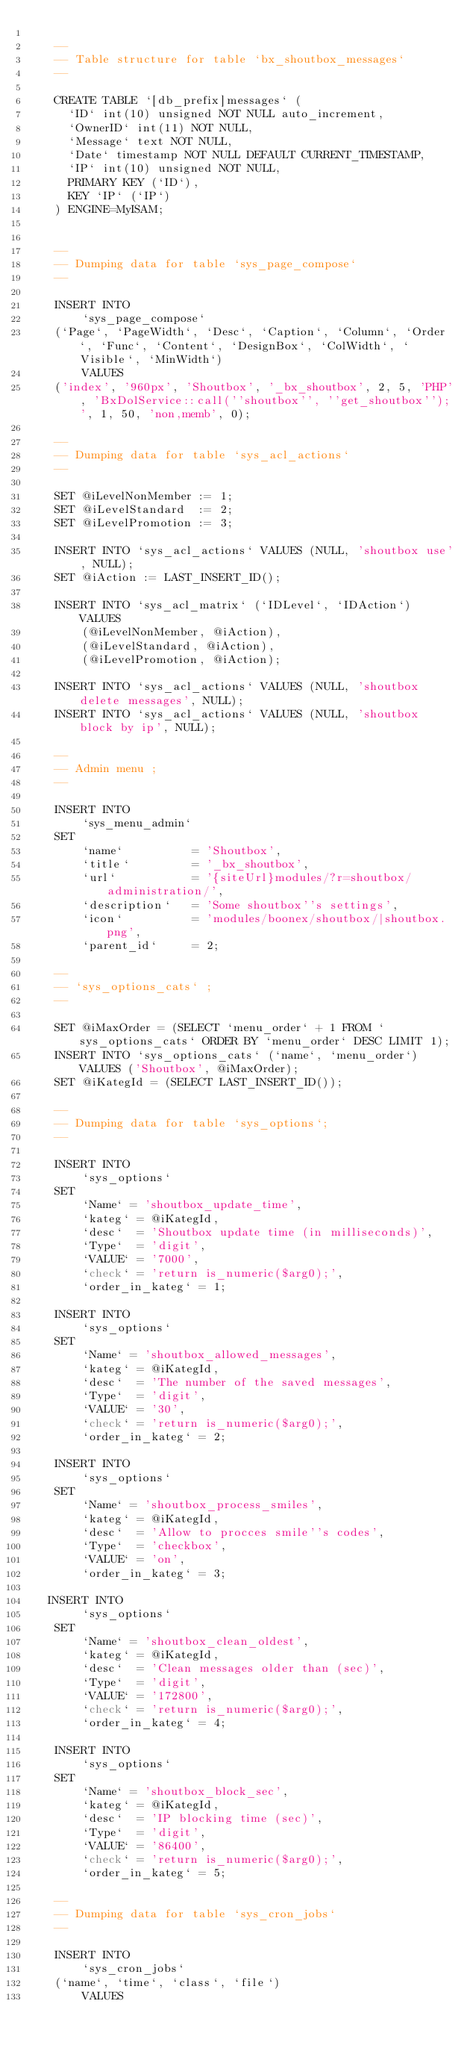Convert code to text. <code><loc_0><loc_0><loc_500><loc_500><_SQL_>
    --
    -- Table structure for table `bx_shoutbox_messages`
    --

    CREATE TABLE `[db_prefix]messages` (
      `ID` int(10) unsigned NOT NULL auto_increment,
      `OwnerID` int(11) NOT NULL,
      `Message` text NOT NULL,
      `Date` timestamp NOT NULL DEFAULT CURRENT_TIMESTAMP,
      `IP` int(10) unsigned NOT NULL,
      PRIMARY KEY (`ID`),
      KEY `IP` (`IP`)
    ) ENGINE=MyISAM;


    --
    -- Dumping data for table `sys_page_compose`
    --

    INSERT INTO 
        `sys_page_compose` 
    (`Page`, `PageWidth`, `Desc`, `Caption`, `Column`, `Order`, `Func`, `Content`, `DesignBox`, `ColWidth`, `Visible`, `MinWidth`)
        VALUES
    ('index', '960px', 'Shoutbox', '_bx_shoutbox', 2, 5, 'PHP', 'BxDolService::call(''shoutbox'', ''get_shoutbox'');', 1, 50, 'non,memb', 0);

    --
    -- Dumping data for table `sys_acl_actions`
    --

    SET @iLevelNonMember := 1;
    SET @iLevelStandard  := 2;
    SET @iLevelPromotion := 3;

    INSERT INTO `sys_acl_actions` VALUES (NULL, 'shoutbox use', NULL);
    SET @iAction := LAST_INSERT_ID();

    INSERT INTO `sys_acl_matrix` (`IDLevel`, `IDAction`) VALUES 
        (@iLevelNonMember, @iAction), 
        (@iLevelStandard, @iAction), 
        (@iLevelPromotion, @iAction);

    INSERT INTO `sys_acl_actions` VALUES (NULL, 'shoutbox delete messages', NULL);
    INSERT INTO `sys_acl_actions` VALUES (NULL, 'shoutbox block by ip', NULL);

    --
    -- Admin menu ;
    --

    INSERT INTO 
        `sys_menu_admin` 
    SET
        `name`          = 'Shoutbox',
        `title`         = '_bx_shoutbox', 
        `url`           = '{siteUrl}modules/?r=shoutbox/administration/',
        `description`   = 'Some shoutbox''s settings',
        `icon`          = 'modules/boonex/shoutbox/|shoutbox.png',
        `parent_id`     = 2;
    
    --
    -- `sys_options_cats` ;
    --

    SET @iMaxOrder = (SELECT `menu_order` + 1 FROM `sys_options_cats` ORDER BY `menu_order` DESC LIMIT 1);
    INSERT INTO `sys_options_cats` (`name`, `menu_order`) VALUES ('Shoutbox', @iMaxOrder);
    SET @iKategId = (SELECT LAST_INSERT_ID());

    --
    -- Dumping data for table `sys_options`;
    --

    INSERT INTO 
        `sys_options` 
    SET
        `Name` = 'shoutbox_update_time',
        `kateg` = @iKategId,
        `desc`  = 'Shoutbox update time (in milliseconds)',
        `Type`  = 'digit',
        `VALUE` = '7000',
        `check` = 'return is_numeric($arg0);',
        `order_in_kateg` = 1;

    INSERT INTO 
        `sys_options` 
    SET
        `Name` = 'shoutbox_allowed_messages',
        `kateg` = @iKategId,
        `desc`  = 'The number of the saved messages',
        `Type`  = 'digit',
        `VALUE` = '30',
        `check` = 'return is_numeric($arg0);',
        `order_in_kateg` = 2;
 
    INSERT INTO 
        `sys_options` 
    SET
        `Name` = 'shoutbox_process_smiles',
        `kateg` = @iKategId,
        `desc`  = 'Allow to procces smile''s codes',
        `Type`  = 'checkbox',
        `VALUE` = 'on',
        `order_in_kateg` = 3;
        
   INSERT INTO 
        `sys_options` 
    SET
        `Name` = 'shoutbox_clean_oldest',
        `kateg` = @iKategId,
        `desc`  = 'Clean messages older than (sec)',
        `Type`  = 'digit',
        `VALUE` = '172800',
        `check` = 'return is_numeric($arg0);',
        `order_in_kateg` = 4;

    INSERT INTO 
        `sys_options` 
    SET
        `Name` = 'shoutbox_block_sec',
        `kateg` = @iKategId,
        `desc`  = 'IP blocking time (sec)',
        `Type`  = 'digit',
        `VALUE` = '86400',
        `check` = 'return is_numeric($arg0);',
        `order_in_kateg` = 5;

    --
    -- Dumping data for table `sys_cron_jobs`
    --

    INSERT INTO 
        `sys_cron_jobs` 
    (`name`, `time`, `class`, `file`)
        VALUES</code> 